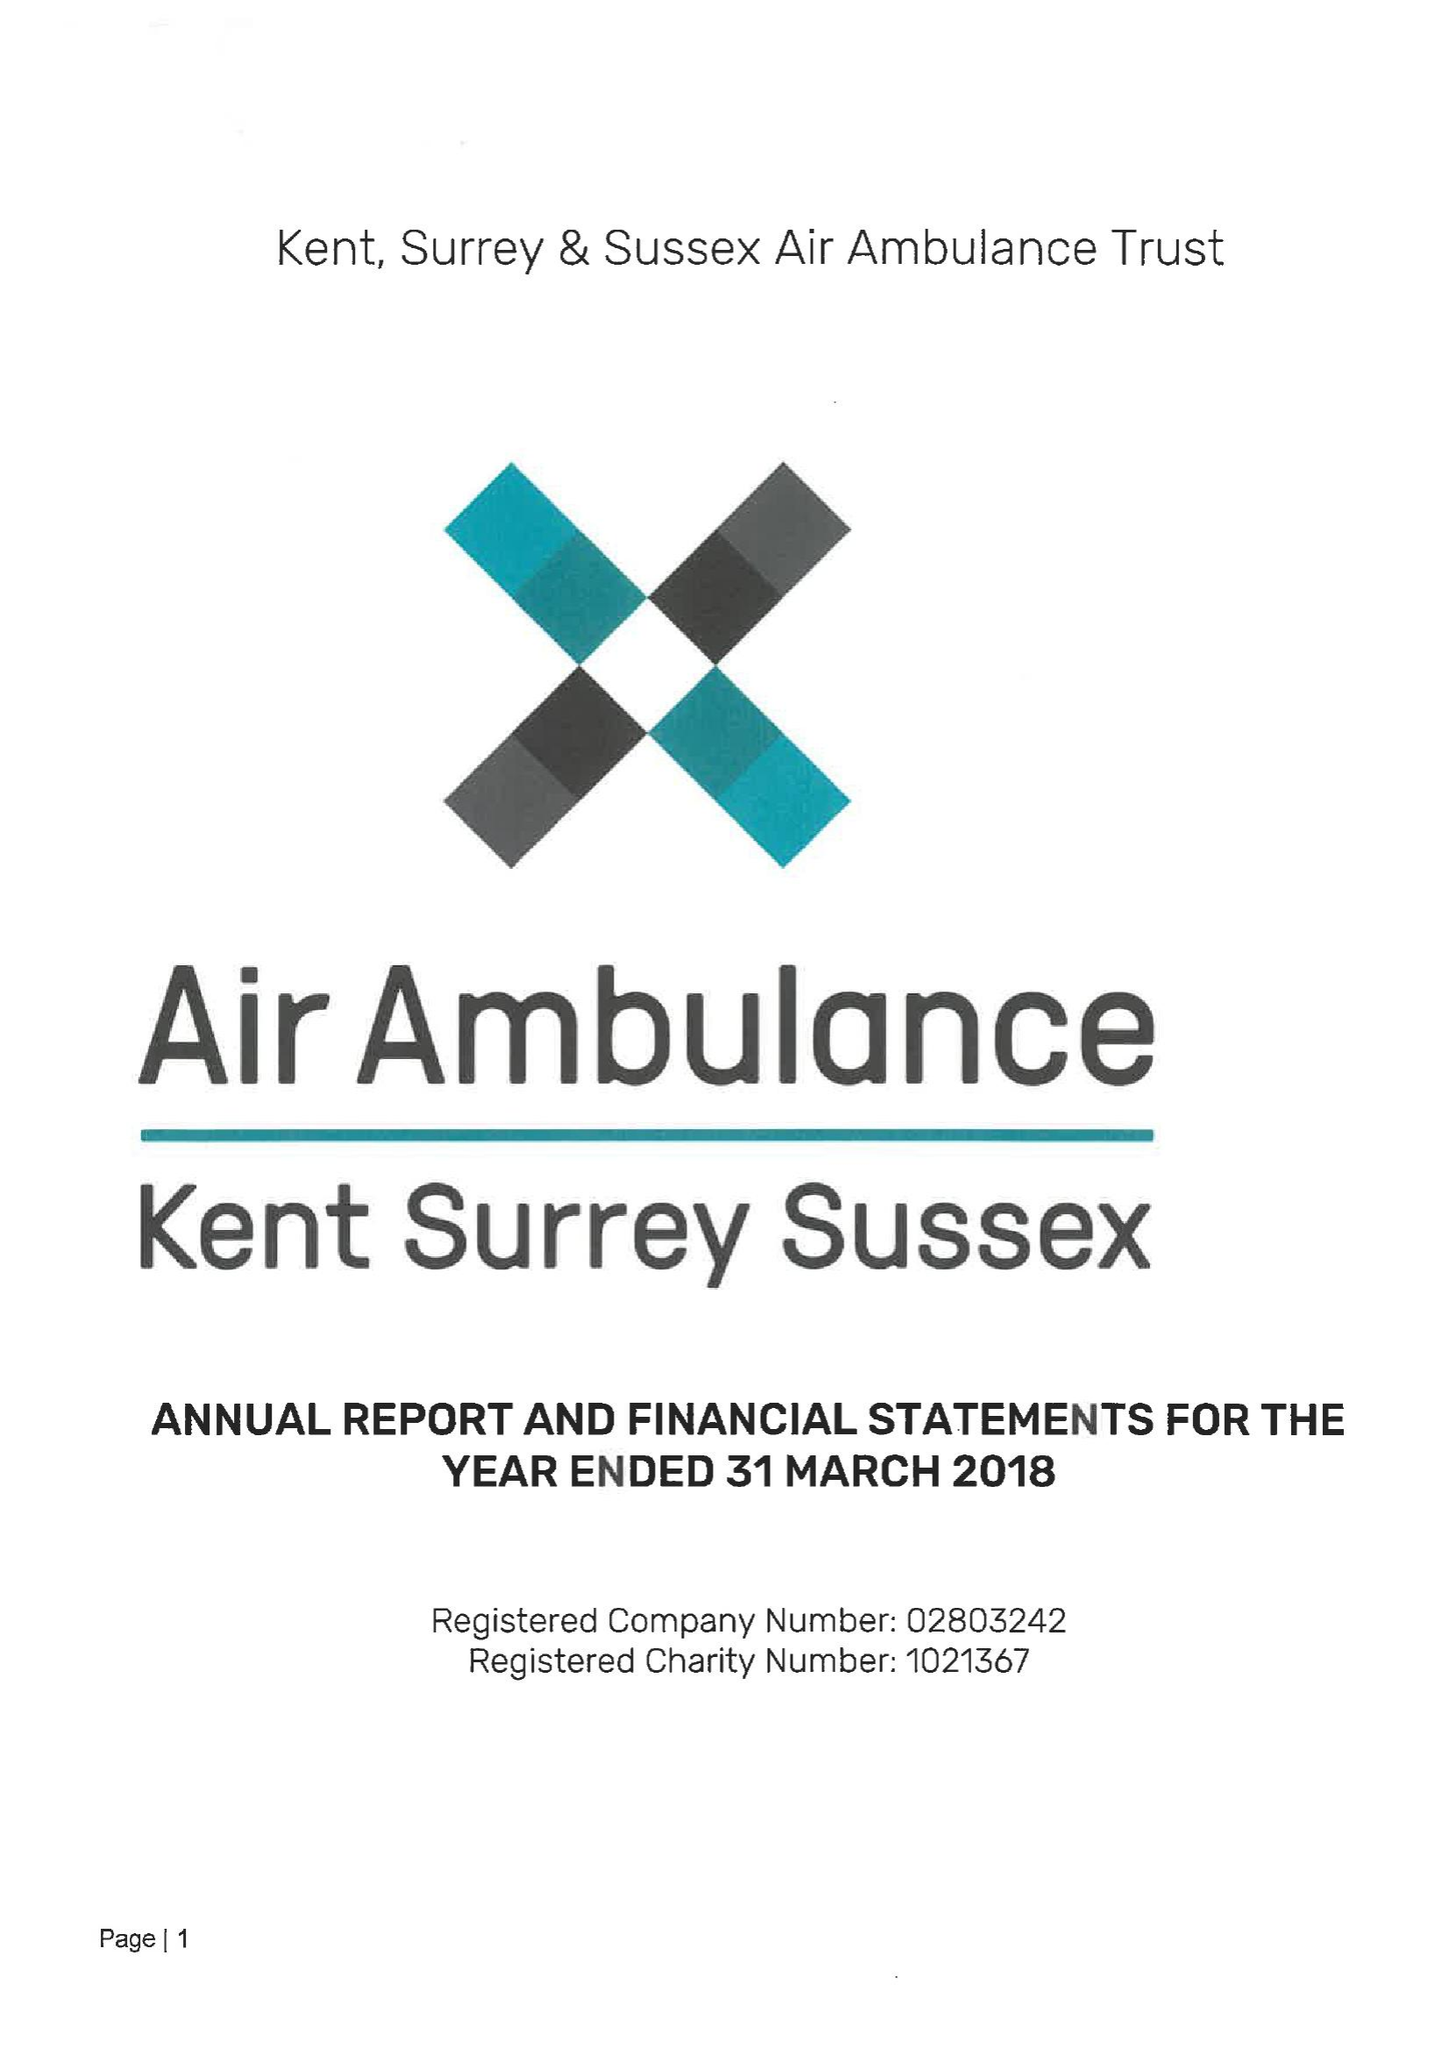What is the value for the address__postcode?
Answer the question using a single word or phrase. ME5 9SD 